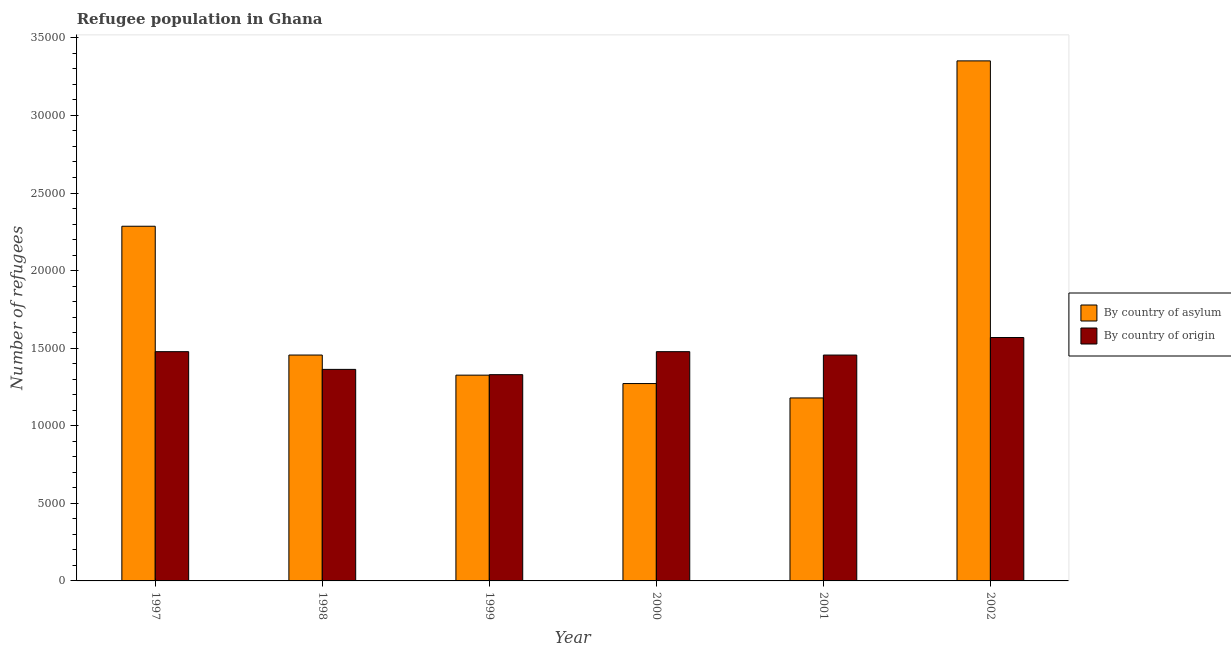Are the number of bars per tick equal to the number of legend labels?
Your response must be concise. Yes. Are the number of bars on each tick of the X-axis equal?
Offer a terse response. Yes. How many bars are there on the 1st tick from the left?
Make the answer very short. 2. What is the number of refugees by country of origin in 2002?
Your response must be concise. 1.57e+04. Across all years, what is the maximum number of refugees by country of origin?
Your response must be concise. 1.57e+04. Across all years, what is the minimum number of refugees by country of origin?
Make the answer very short. 1.33e+04. In which year was the number of refugees by country of origin maximum?
Your answer should be very brief. 2002. In which year was the number of refugees by country of asylum minimum?
Provide a succinct answer. 2001. What is the total number of refugees by country of origin in the graph?
Give a very brief answer. 8.67e+04. What is the difference between the number of refugees by country of asylum in 1997 and that in 2002?
Give a very brief answer. -1.07e+04. What is the difference between the number of refugees by country of asylum in 1997 and the number of refugees by country of origin in 2001?
Offer a terse response. 1.11e+04. What is the average number of refugees by country of origin per year?
Provide a short and direct response. 1.45e+04. In the year 2000, what is the difference between the number of refugees by country of asylum and number of refugees by country of origin?
Give a very brief answer. 0. What is the ratio of the number of refugees by country of asylum in 1997 to that in 1998?
Provide a short and direct response. 1.57. Is the difference between the number of refugees by country of asylum in 1998 and 2000 greater than the difference between the number of refugees by country of origin in 1998 and 2000?
Keep it short and to the point. No. What is the difference between the highest and the second highest number of refugees by country of origin?
Provide a short and direct response. 911. What is the difference between the highest and the lowest number of refugees by country of origin?
Offer a terse response. 2393. In how many years, is the number of refugees by country of asylum greater than the average number of refugees by country of asylum taken over all years?
Make the answer very short. 2. Is the sum of the number of refugees by country of origin in 1997 and 2000 greater than the maximum number of refugees by country of asylum across all years?
Your answer should be very brief. Yes. What does the 2nd bar from the left in 2000 represents?
Give a very brief answer. By country of origin. What does the 1st bar from the right in 1998 represents?
Offer a terse response. By country of origin. How many bars are there?
Make the answer very short. 12. What is the difference between two consecutive major ticks on the Y-axis?
Offer a terse response. 5000. Are the values on the major ticks of Y-axis written in scientific E-notation?
Your response must be concise. No. Where does the legend appear in the graph?
Make the answer very short. Center right. How many legend labels are there?
Offer a very short reply. 2. How are the legend labels stacked?
Offer a very short reply. Vertical. What is the title of the graph?
Ensure brevity in your answer.  Refugee population in Ghana. Does "Unregistered firms" appear as one of the legend labels in the graph?
Provide a short and direct response. No. What is the label or title of the X-axis?
Make the answer very short. Year. What is the label or title of the Y-axis?
Provide a short and direct response. Number of refugees. What is the Number of refugees of By country of asylum in 1997?
Ensure brevity in your answer.  2.29e+04. What is the Number of refugees in By country of origin in 1997?
Your answer should be very brief. 1.48e+04. What is the Number of refugees of By country of asylum in 1998?
Give a very brief answer. 1.46e+04. What is the Number of refugees of By country of origin in 1998?
Your response must be concise. 1.36e+04. What is the Number of refugees in By country of asylum in 1999?
Your response must be concise. 1.33e+04. What is the Number of refugees of By country of origin in 1999?
Ensure brevity in your answer.  1.33e+04. What is the Number of refugees of By country of asylum in 2000?
Your response must be concise. 1.27e+04. What is the Number of refugees of By country of origin in 2000?
Make the answer very short. 1.48e+04. What is the Number of refugees in By country of asylum in 2001?
Ensure brevity in your answer.  1.18e+04. What is the Number of refugees in By country of origin in 2001?
Provide a short and direct response. 1.46e+04. What is the Number of refugees of By country of asylum in 2002?
Your answer should be compact. 3.35e+04. What is the Number of refugees in By country of origin in 2002?
Make the answer very short. 1.57e+04. Across all years, what is the maximum Number of refugees of By country of asylum?
Make the answer very short. 3.35e+04. Across all years, what is the maximum Number of refugees in By country of origin?
Your answer should be compact. 1.57e+04. Across all years, what is the minimum Number of refugees of By country of asylum?
Give a very brief answer. 1.18e+04. Across all years, what is the minimum Number of refugees of By country of origin?
Offer a terse response. 1.33e+04. What is the total Number of refugees in By country of asylum in the graph?
Make the answer very short. 1.09e+05. What is the total Number of refugees in By country of origin in the graph?
Give a very brief answer. 8.67e+04. What is the difference between the Number of refugees of By country of asylum in 1997 and that in 1998?
Offer a terse response. 8301. What is the difference between the Number of refugees of By country of origin in 1997 and that in 1998?
Keep it short and to the point. 1142. What is the difference between the Number of refugees of By country of asylum in 1997 and that in 1999?
Keep it short and to the point. 9597. What is the difference between the Number of refugees of By country of origin in 1997 and that in 1999?
Provide a succinct answer. 1482. What is the difference between the Number of refugees of By country of asylum in 1997 and that in 2000?
Keep it short and to the point. 1.01e+04. What is the difference between the Number of refugees in By country of asylum in 1997 and that in 2001?
Your answer should be very brief. 1.11e+04. What is the difference between the Number of refugees of By country of origin in 1997 and that in 2001?
Provide a succinct answer. 219. What is the difference between the Number of refugees in By country of asylum in 1997 and that in 2002?
Your answer should be compact. -1.07e+04. What is the difference between the Number of refugees in By country of origin in 1997 and that in 2002?
Your response must be concise. -911. What is the difference between the Number of refugees of By country of asylum in 1998 and that in 1999?
Provide a short and direct response. 1296. What is the difference between the Number of refugees of By country of origin in 1998 and that in 1999?
Provide a succinct answer. 340. What is the difference between the Number of refugees of By country of asylum in 1998 and that in 2000?
Provide a short and direct response. 1837. What is the difference between the Number of refugees in By country of origin in 1998 and that in 2000?
Keep it short and to the point. -1142. What is the difference between the Number of refugees of By country of asylum in 1998 and that in 2001?
Keep it short and to the point. 2765. What is the difference between the Number of refugees of By country of origin in 1998 and that in 2001?
Your answer should be very brief. -923. What is the difference between the Number of refugees in By country of asylum in 1998 and that in 2002?
Provide a succinct answer. -1.90e+04. What is the difference between the Number of refugees in By country of origin in 1998 and that in 2002?
Offer a terse response. -2053. What is the difference between the Number of refugees of By country of asylum in 1999 and that in 2000?
Your answer should be very brief. 541. What is the difference between the Number of refugees in By country of origin in 1999 and that in 2000?
Offer a terse response. -1482. What is the difference between the Number of refugees in By country of asylum in 1999 and that in 2001?
Make the answer very short. 1469. What is the difference between the Number of refugees in By country of origin in 1999 and that in 2001?
Make the answer very short. -1263. What is the difference between the Number of refugees of By country of asylum in 1999 and that in 2002?
Your response must be concise. -2.03e+04. What is the difference between the Number of refugees of By country of origin in 1999 and that in 2002?
Your answer should be compact. -2393. What is the difference between the Number of refugees in By country of asylum in 2000 and that in 2001?
Give a very brief answer. 928. What is the difference between the Number of refugees of By country of origin in 2000 and that in 2001?
Offer a very short reply. 219. What is the difference between the Number of refugees in By country of asylum in 2000 and that in 2002?
Provide a short and direct response. -2.08e+04. What is the difference between the Number of refugees of By country of origin in 2000 and that in 2002?
Your answer should be very brief. -911. What is the difference between the Number of refugees of By country of asylum in 2001 and that in 2002?
Provide a short and direct response. -2.17e+04. What is the difference between the Number of refugees in By country of origin in 2001 and that in 2002?
Keep it short and to the point. -1130. What is the difference between the Number of refugees of By country of asylum in 1997 and the Number of refugees of By country of origin in 1998?
Give a very brief answer. 9225. What is the difference between the Number of refugees in By country of asylum in 1997 and the Number of refugees in By country of origin in 1999?
Provide a short and direct response. 9565. What is the difference between the Number of refugees in By country of asylum in 1997 and the Number of refugees in By country of origin in 2000?
Your answer should be very brief. 8083. What is the difference between the Number of refugees of By country of asylum in 1997 and the Number of refugees of By country of origin in 2001?
Ensure brevity in your answer.  8302. What is the difference between the Number of refugees of By country of asylum in 1997 and the Number of refugees of By country of origin in 2002?
Provide a short and direct response. 7172. What is the difference between the Number of refugees in By country of asylum in 1998 and the Number of refugees in By country of origin in 1999?
Provide a short and direct response. 1264. What is the difference between the Number of refugees in By country of asylum in 1998 and the Number of refugees in By country of origin in 2000?
Ensure brevity in your answer.  -218. What is the difference between the Number of refugees in By country of asylum in 1998 and the Number of refugees in By country of origin in 2001?
Your answer should be compact. 1. What is the difference between the Number of refugees of By country of asylum in 1998 and the Number of refugees of By country of origin in 2002?
Make the answer very short. -1129. What is the difference between the Number of refugees of By country of asylum in 1999 and the Number of refugees of By country of origin in 2000?
Your response must be concise. -1514. What is the difference between the Number of refugees in By country of asylum in 1999 and the Number of refugees in By country of origin in 2001?
Give a very brief answer. -1295. What is the difference between the Number of refugees in By country of asylum in 1999 and the Number of refugees in By country of origin in 2002?
Offer a very short reply. -2425. What is the difference between the Number of refugees in By country of asylum in 2000 and the Number of refugees in By country of origin in 2001?
Your answer should be compact. -1836. What is the difference between the Number of refugees of By country of asylum in 2000 and the Number of refugees of By country of origin in 2002?
Provide a succinct answer. -2966. What is the difference between the Number of refugees in By country of asylum in 2001 and the Number of refugees in By country of origin in 2002?
Give a very brief answer. -3894. What is the average Number of refugees of By country of asylum per year?
Make the answer very short. 1.81e+04. What is the average Number of refugees in By country of origin per year?
Provide a short and direct response. 1.45e+04. In the year 1997, what is the difference between the Number of refugees of By country of asylum and Number of refugees of By country of origin?
Offer a terse response. 8083. In the year 1998, what is the difference between the Number of refugees of By country of asylum and Number of refugees of By country of origin?
Ensure brevity in your answer.  924. In the year 1999, what is the difference between the Number of refugees of By country of asylum and Number of refugees of By country of origin?
Provide a short and direct response. -32. In the year 2000, what is the difference between the Number of refugees in By country of asylum and Number of refugees in By country of origin?
Keep it short and to the point. -2055. In the year 2001, what is the difference between the Number of refugees in By country of asylum and Number of refugees in By country of origin?
Your answer should be very brief. -2764. In the year 2002, what is the difference between the Number of refugees in By country of asylum and Number of refugees in By country of origin?
Keep it short and to the point. 1.78e+04. What is the ratio of the Number of refugees in By country of asylum in 1997 to that in 1998?
Offer a terse response. 1.57. What is the ratio of the Number of refugees of By country of origin in 1997 to that in 1998?
Offer a terse response. 1.08. What is the ratio of the Number of refugees in By country of asylum in 1997 to that in 1999?
Make the answer very short. 1.72. What is the ratio of the Number of refugees of By country of origin in 1997 to that in 1999?
Give a very brief answer. 1.11. What is the ratio of the Number of refugees of By country of asylum in 1997 to that in 2000?
Offer a very short reply. 1.8. What is the ratio of the Number of refugees of By country of origin in 1997 to that in 2000?
Offer a terse response. 1. What is the ratio of the Number of refugees of By country of asylum in 1997 to that in 2001?
Offer a terse response. 1.94. What is the ratio of the Number of refugees of By country of asylum in 1997 to that in 2002?
Keep it short and to the point. 0.68. What is the ratio of the Number of refugees of By country of origin in 1997 to that in 2002?
Your response must be concise. 0.94. What is the ratio of the Number of refugees of By country of asylum in 1998 to that in 1999?
Ensure brevity in your answer.  1.1. What is the ratio of the Number of refugees in By country of origin in 1998 to that in 1999?
Your answer should be compact. 1.03. What is the ratio of the Number of refugees of By country of asylum in 1998 to that in 2000?
Offer a terse response. 1.14. What is the ratio of the Number of refugees in By country of origin in 1998 to that in 2000?
Your answer should be compact. 0.92. What is the ratio of the Number of refugees of By country of asylum in 1998 to that in 2001?
Your response must be concise. 1.23. What is the ratio of the Number of refugees in By country of origin in 1998 to that in 2001?
Keep it short and to the point. 0.94. What is the ratio of the Number of refugees of By country of asylum in 1998 to that in 2002?
Your answer should be compact. 0.43. What is the ratio of the Number of refugees of By country of origin in 1998 to that in 2002?
Provide a succinct answer. 0.87. What is the ratio of the Number of refugees in By country of asylum in 1999 to that in 2000?
Give a very brief answer. 1.04. What is the ratio of the Number of refugees of By country of origin in 1999 to that in 2000?
Provide a succinct answer. 0.9. What is the ratio of the Number of refugees of By country of asylum in 1999 to that in 2001?
Ensure brevity in your answer.  1.12. What is the ratio of the Number of refugees in By country of origin in 1999 to that in 2001?
Provide a short and direct response. 0.91. What is the ratio of the Number of refugees of By country of asylum in 1999 to that in 2002?
Your answer should be compact. 0.4. What is the ratio of the Number of refugees in By country of origin in 1999 to that in 2002?
Give a very brief answer. 0.85. What is the ratio of the Number of refugees of By country of asylum in 2000 to that in 2001?
Give a very brief answer. 1.08. What is the ratio of the Number of refugees in By country of origin in 2000 to that in 2001?
Your answer should be compact. 1.01. What is the ratio of the Number of refugees in By country of asylum in 2000 to that in 2002?
Give a very brief answer. 0.38. What is the ratio of the Number of refugees in By country of origin in 2000 to that in 2002?
Provide a succinct answer. 0.94. What is the ratio of the Number of refugees in By country of asylum in 2001 to that in 2002?
Offer a very short reply. 0.35. What is the ratio of the Number of refugees in By country of origin in 2001 to that in 2002?
Give a very brief answer. 0.93. What is the difference between the highest and the second highest Number of refugees in By country of asylum?
Provide a succinct answer. 1.07e+04. What is the difference between the highest and the second highest Number of refugees in By country of origin?
Provide a short and direct response. 911. What is the difference between the highest and the lowest Number of refugees in By country of asylum?
Offer a terse response. 2.17e+04. What is the difference between the highest and the lowest Number of refugees of By country of origin?
Offer a terse response. 2393. 